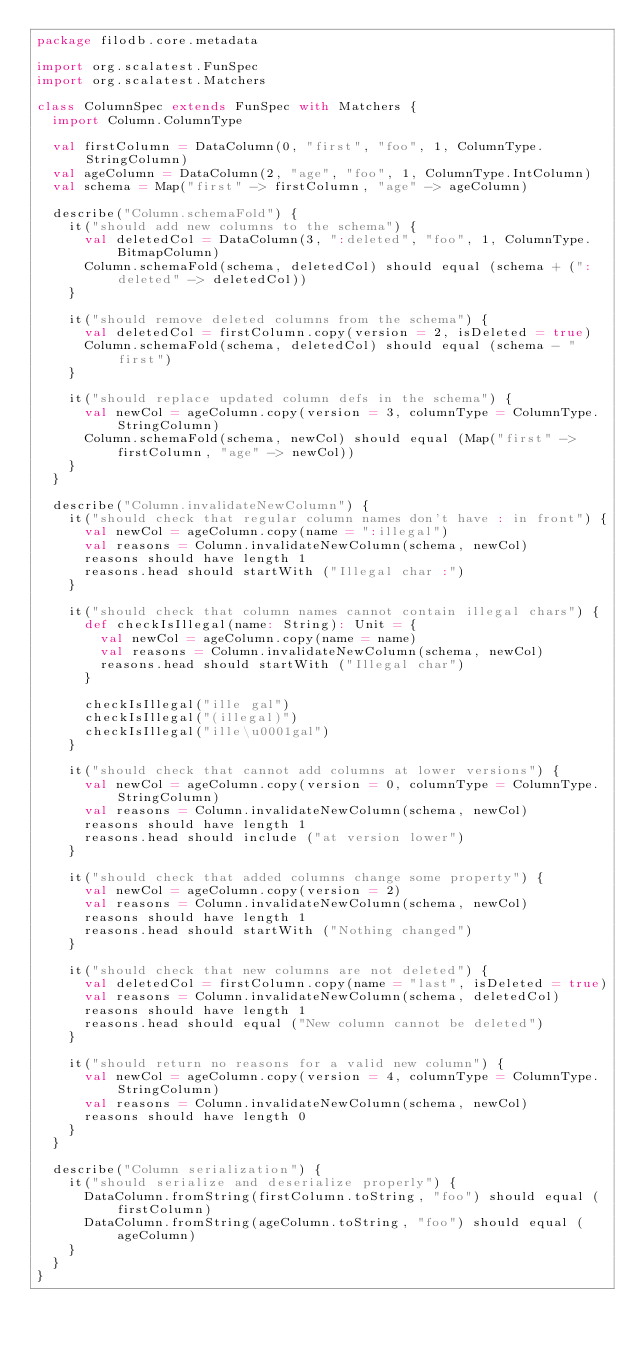<code> <loc_0><loc_0><loc_500><loc_500><_Scala_>package filodb.core.metadata

import org.scalatest.FunSpec
import org.scalatest.Matchers

class ColumnSpec extends FunSpec with Matchers {
  import Column.ColumnType

  val firstColumn = DataColumn(0, "first", "foo", 1, ColumnType.StringColumn)
  val ageColumn = DataColumn(2, "age", "foo", 1, ColumnType.IntColumn)
  val schema = Map("first" -> firstColumn, "age" -> ageColumn)

  describe("Column.schemaFold") {
    it("should add new columns to the schema") {
      val deletedCol = DataColumn(3, ":deleted", "foo", 1, ColumnType.BitmapColumn)
      Column.schemaFold(schema, deletedCol) should equal (schema + (":deleted" -> deletedCol))
    }

    it("should remove deleted columns from the schema") {
      val deletedCol = firstColumn.copy(version = 2, isDeleted = true)
      Column.schemaFold(schema, deletedCol) should equal (schema - "first")
    }

    it("should replace updated column defs in the schema") {
      val newCol = ageColumn.copy(version = 3, columnType = ColumnType.StringColumn)
      Column.schemaFold(schema, newCol) should equal (Map("first" -> firstColumn, "age" -> newCol))
    }
  }

  describe("Column.invalidateNewColumn") {
    it("should check that regular column names don't have : in front") {
      val newCol = ageColumn.copy(name = ":illegal")
      val reasons = Column.invalidateNewColumn(schema, newCol)
      reasons should have length 1
      reasons.head should startWith ("Illegal char :")
    }

    it("should check that column names cannot contain illegal chars") {
      def checkIsIllegal(name: String): Unit = {
        val newCol = ageColumn.copy(name = name)
        val reasons = Column.invalidateNewColumn(schema, newCol)
        reasons.head should startWith ("Illegal char")
      }

      checkIsIllegal("ille gal")
      checkIsIllegal("(illegal)")
      checkIsIllegal("ille\u0001gal")
    }

    it("should check that cannot add columns at lower versions") {
      val newCol = ageColumn.copy(version = 0, columnType = ColumnType.StringColumn)
      val reasons = Column.invalidateNewColumn(schema, newCol)
      reasons should have length 1
      reasons.head should include ("at version lower")
    }

    it("should check that added columns change some property") {
      val newCol = ageColumn.copy(version = 2)
      val reasons = Column.invalidateNewColumn(schema, newCol)
      reasons should have length 1
      reasons.head should startWith ("Nothing changed")
    }

    it("should check that new columns are not deleted") {
      val deletedCol = firstColumn.copy(name = "last", isDeleted = true)
      val reasons = Column.invalidateNewColumn(schema, deletedCol)
      reasons should have length 1
      reasons.head should equal ("New column cannot be deleted")
    }

    it("should return no reasons for a valid new column") {
      val newCol = ageColumn.copy(version = 4, columnType = ColumnType.StringColumn)
      val reasons = Column.invalidateNewColumn(schema, newCol)
      reasons should have length 0
    }
  }

  describe("Column serialization") {
    it("should serialize and deserialize properly") {
      DataColumn.fromString(firstColumn.toString, "foo") should equal (firstColumn)
      DataColumn.fromString(ageColumn.toString, "foo") should equal (ageColumn)
    }
  }
}</code> 